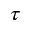<formula> <loc_0><loc_0><loc_500><loc_500>\tau</formula> 